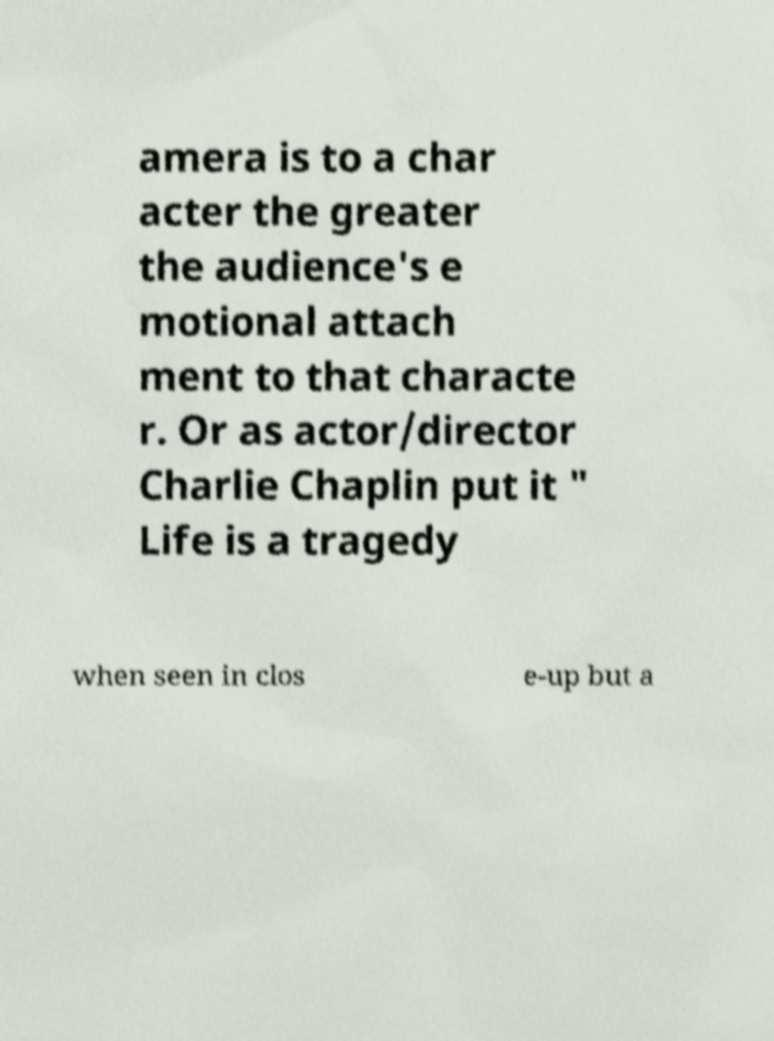Can you accurately transcribe the text from the provided image for me? amera is to a char acter the greater the audience's e motional attach ment to that characte r. Or as actor/director Charlie Chaplin put it " Life is a tragedy when seen in clos e-up but a 